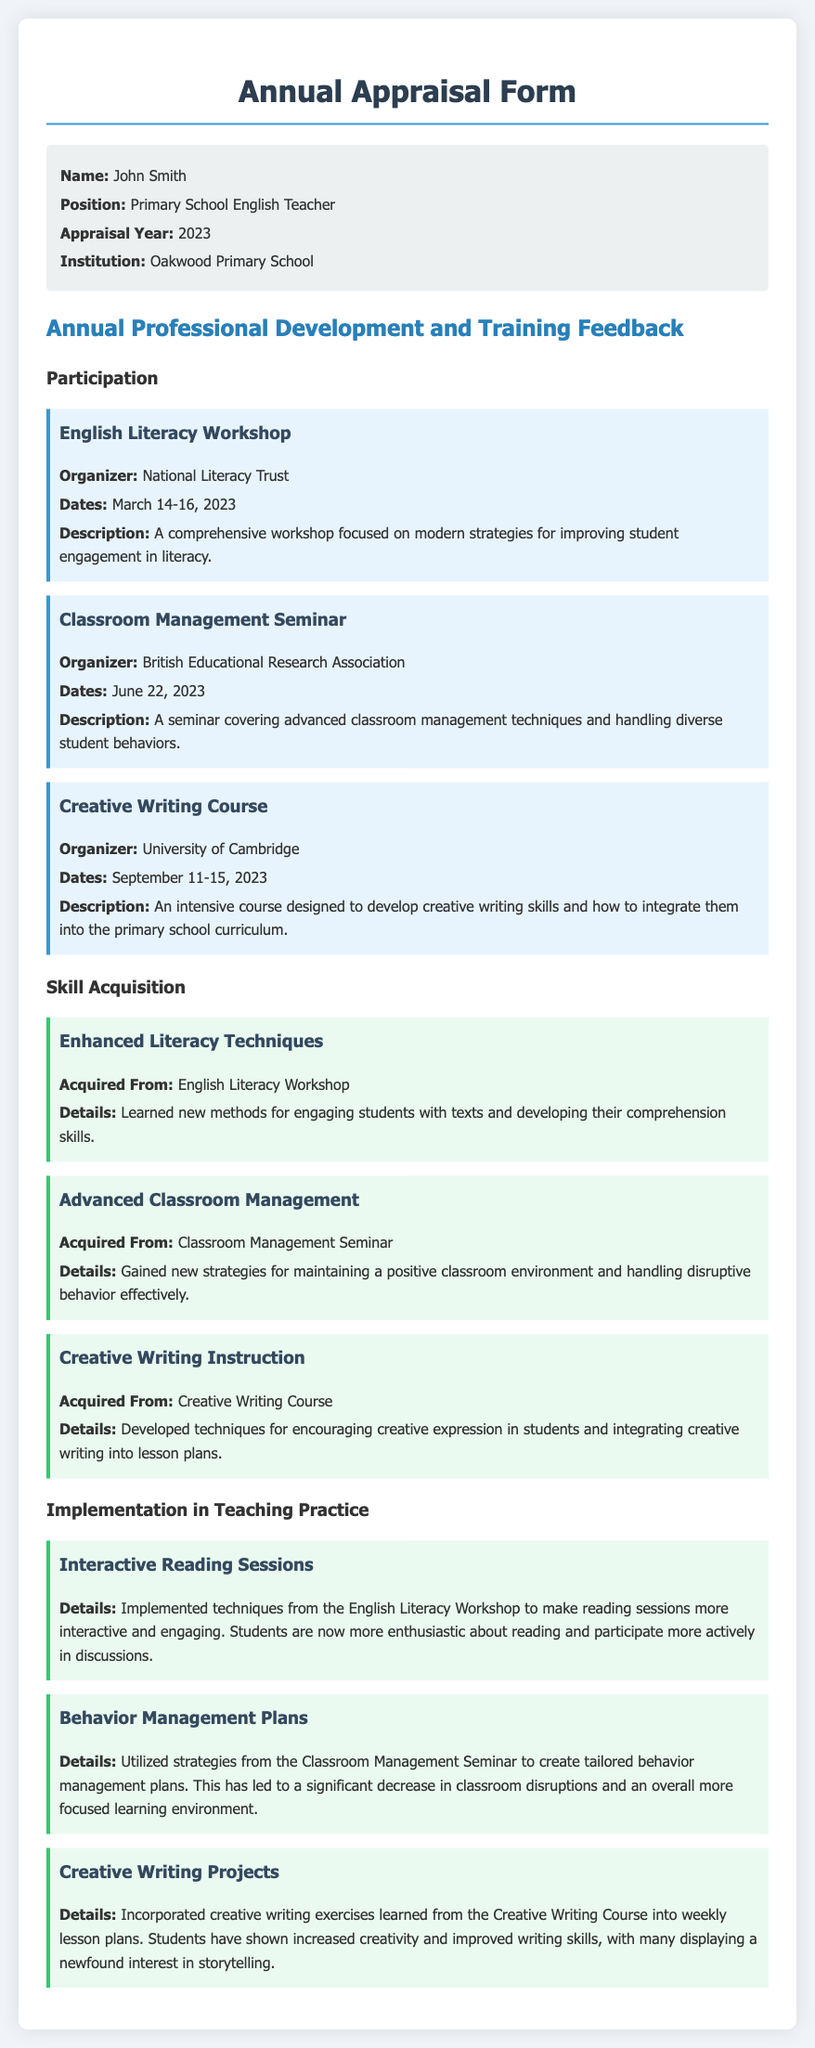what is the name of the teacher? The document lists the teacher's name at the top, which is John Smith.
Answer: John Smith what school does the teacher work at? The institution where the teacher is employed is mentioned in the personal information section.
Answer: Oakwood Primary School how many workshops or courses did the teacher participate in? The document lists three events the teacher attended, providing a total count.
Answer: 3 which organization hosted the Classroom Management Seminar? The organizer of the Classroom Management Seminar is indicated in the document.
Answer: British Educational Research Association what dates did the Creative Writing Course take place? The specific dates for the Creative Writing Course are provided within the event description.
Answer: September 11-15, 2023 what technique was implemented in Interactive Reading Sessions? The document explains the implementation of techniques from the English Literacy Workshop.
Answer: Techniques from the English Literacy Workshop which skill was acquired from the Creative Writing Course? The document specifies the skill obtained during the Creative Writing Course.
Answer: Creative Writing Instruction how did behavior management plans affect classroom disruption? The document states that the plans led to a reduction of disruptions.
Answer: Significant decrease what was a key outcome of the Creative Writing Projects? The document highlights an improved interest in storytelling as a result of the projects.
Answer: Increased creativity and improved writing skills 